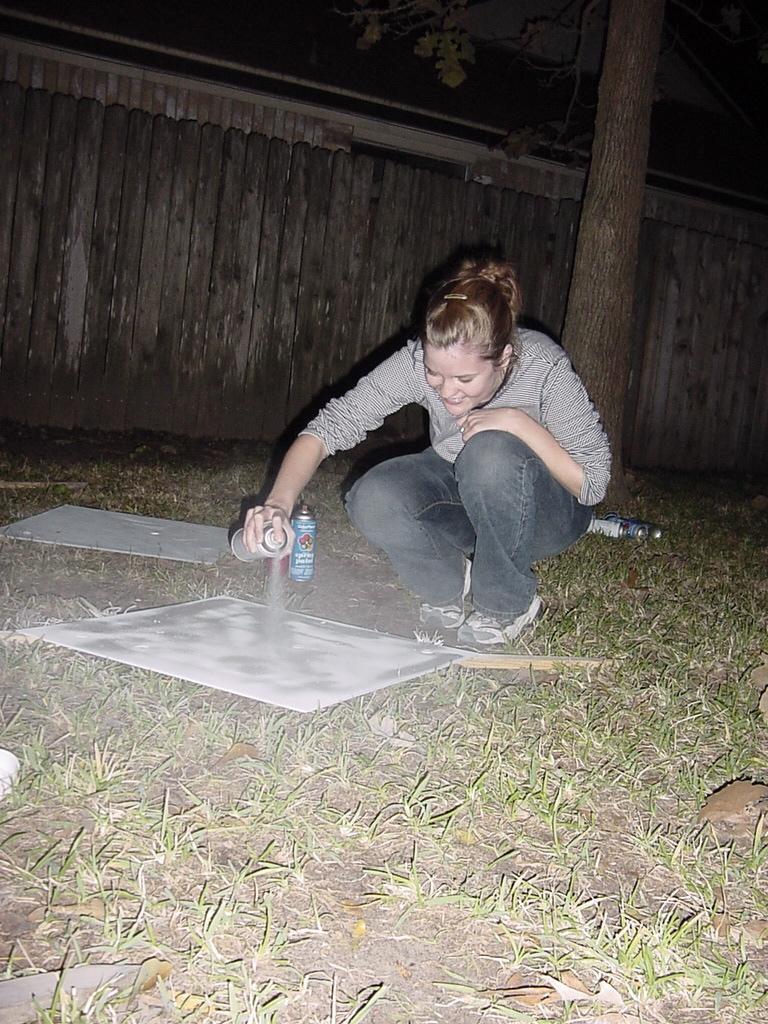Please provide a concise description of this image. In this picture I can see a woman. The woman is in squat position and holding some object in the hand. On the ground I can see some objects, bottle and grass. In the background I can see a tree and a fence. 